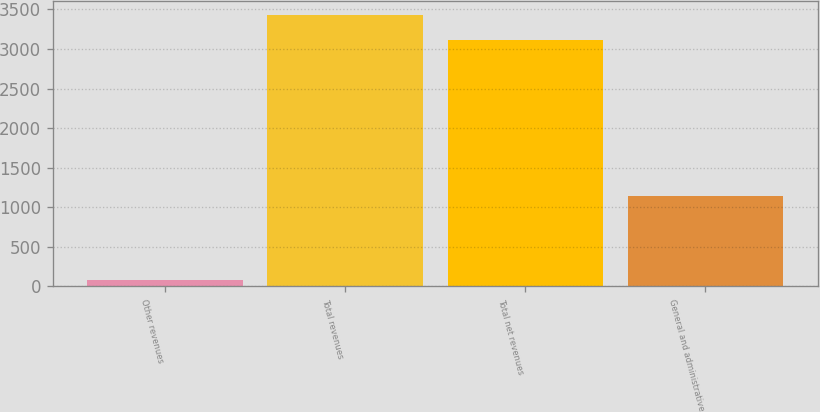Convert chart to OTSL. <chart><loc_0><loc_0><loc_500><loc_500><bar_chart><fcel>Other revenues<fcel>Total revenues<fcel>Total net revenues<fcel>General and administrative<nl><fcel>80<fcel>3430.8<fcel>3110<fcel>1138<nl></chart> 